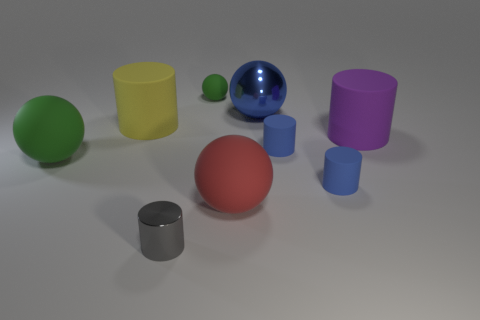There is a big object that is the same color as the tiny matte sphere; what is its shape?
Provide a succinct answer. Sphere. What number of other objects are the same color as the small ball?
Make the answer very short. 1. The purple object that is made of the same material as the big green thing is what shape?
Provide a succinct answer. Cylinder. Does the metal thing on the right side of the small gray shiny object have the same size as the green matte sphere in front of the small ball?
Make the answer very short. Yes. What color is the big matte ball that is to the right of the shiny cylinder?
Offer a terse response. Red. What material is the large cylinder that is to the left of the blue object behind the purple cylinder?
Provide a succinct answer. Rubber. The big red rubber object has what shape?
Ensure brevity in your answer.  Sphere. There is a red thing that is the same shape as the large green rubber thing; what is it made of?
Your response must be concise. Rubber. What number of purple cylinders are the same size as the red sphere?
Keep it short and to the point. 1. There is a green ball behind the large purple rubber object; is there a yellow object to the right of it?
Ensure brevity in your answer.  No. 